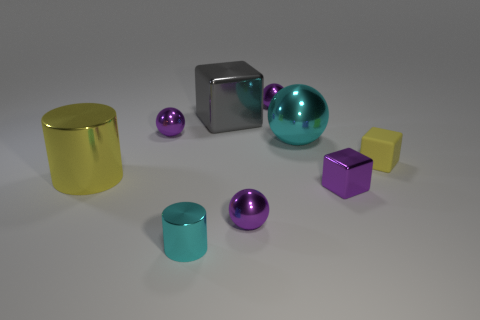Are there any objects that seem to be the same color? Yes, there are pairs of objects with matching colors. The two purple objects, which are a cube and a sphere, share the same color as do the two cyan-colored cylindrical objects.  Do the objects with matching colors also share similar shapes? Not necessarily. While the two cyan objects are both cylindrical in shape, the purple objects consist of a cube and a sphere, indicating that color-matching does not imply shape-matching in this image. 